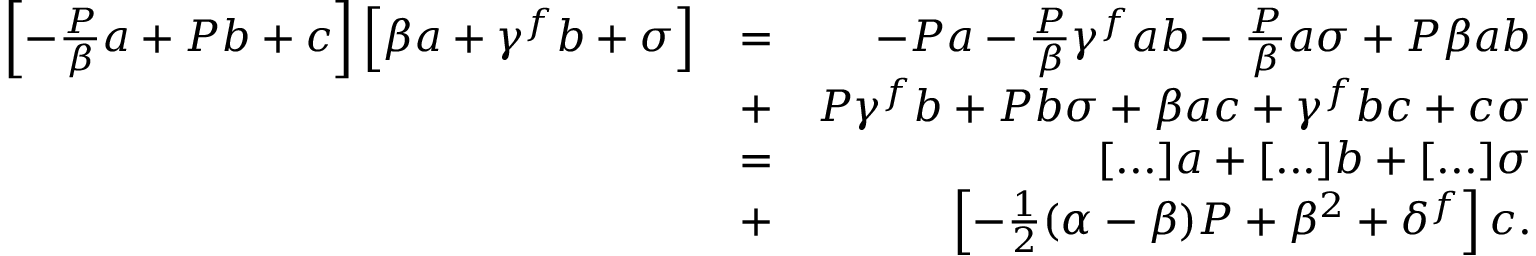<formula> <loc_0><loc_0><loc_500><loc_500>\begin{array} { r l r } { \left [ - \frac { P } { \beta } a + P b + c \right ] \left [ \beta a + \gamma ^ { f } b + \sigma \right ] } & { = } & { - P a - \frac { P } { \beta } \gamma ^ { f } a b - \frac { P } { \beta } a \sigma + P \beta a b } \\ & { + } & { P \gamma ^ { f } b + P b \sigma + \beta a c + \gamma ^ { f } b c + c \sigma } \\ & { = } & { [ \dots ] a + [ \dots ] b + [ \dots ] \sigma } \\ & { + } & { \left [ - \frac { 1 } { 2 } ( \alpha - \beta ) P + \beta ^ { 2 } + \delta ^ { f } \right ] c . } \end{array}</formula> 